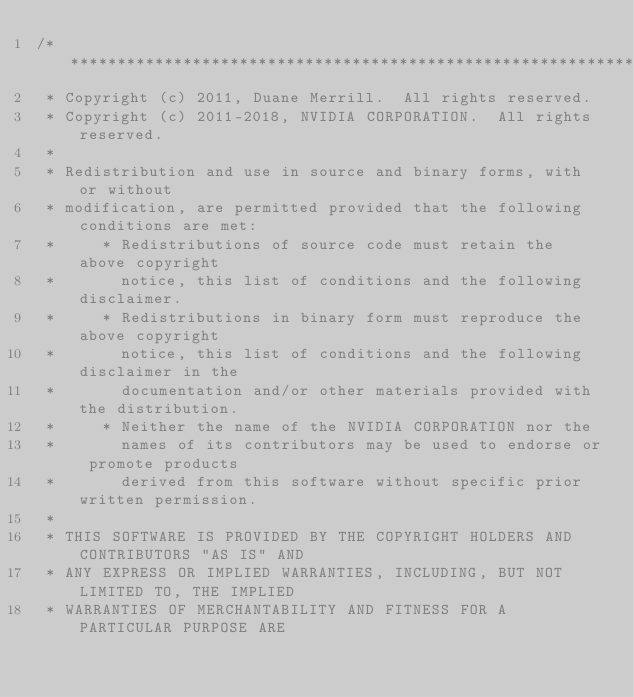<code> <loc_0><loc_0><loc_500><loc_500><_Cuda_>/******************************************************************************
 * Copyright (c) 2011, Duane Merrill.  All rights reserved.
 * Copyright (c) 2011-2018, NVIDIA CORPORATION.  All rights reserved.
 *
 * Redistribution and use in source and binary forms, with or without
 * modification, are permitted provided that the following conditions are met:
 *     * Redistributions of source code must retain the above copyright
 *       notice, this list of conditions and the following disclaimer.
 *     * Redistributions in binary form must reproduce the above copyright
 *       notice, this list of conditions and the following disclaimer in the
 *       documentation and/or other materials provided with the distribution.
 *     * Neither the name of the NVIDIA CORPORATION nor the
 *       names of its contributors may be used to endorse or promote products
 *       derived from this software without specific prior written permission.
 *
 * THIS SOFTWARE IS PROVIDED BY THE COPYRIGHT HOLDERS AND CONTRIBUTORS "AS IS" AND
 * ANY EXPRESS OR IMPLIED WARRANTIES, INCLUDING, BUT NOT LIMITED TO, THE IMPLIED
 * WARRANTIES OF MERCHANTABILITY AND FITNESS FOR A PARTICULAR PURPOSE ARE</code> 